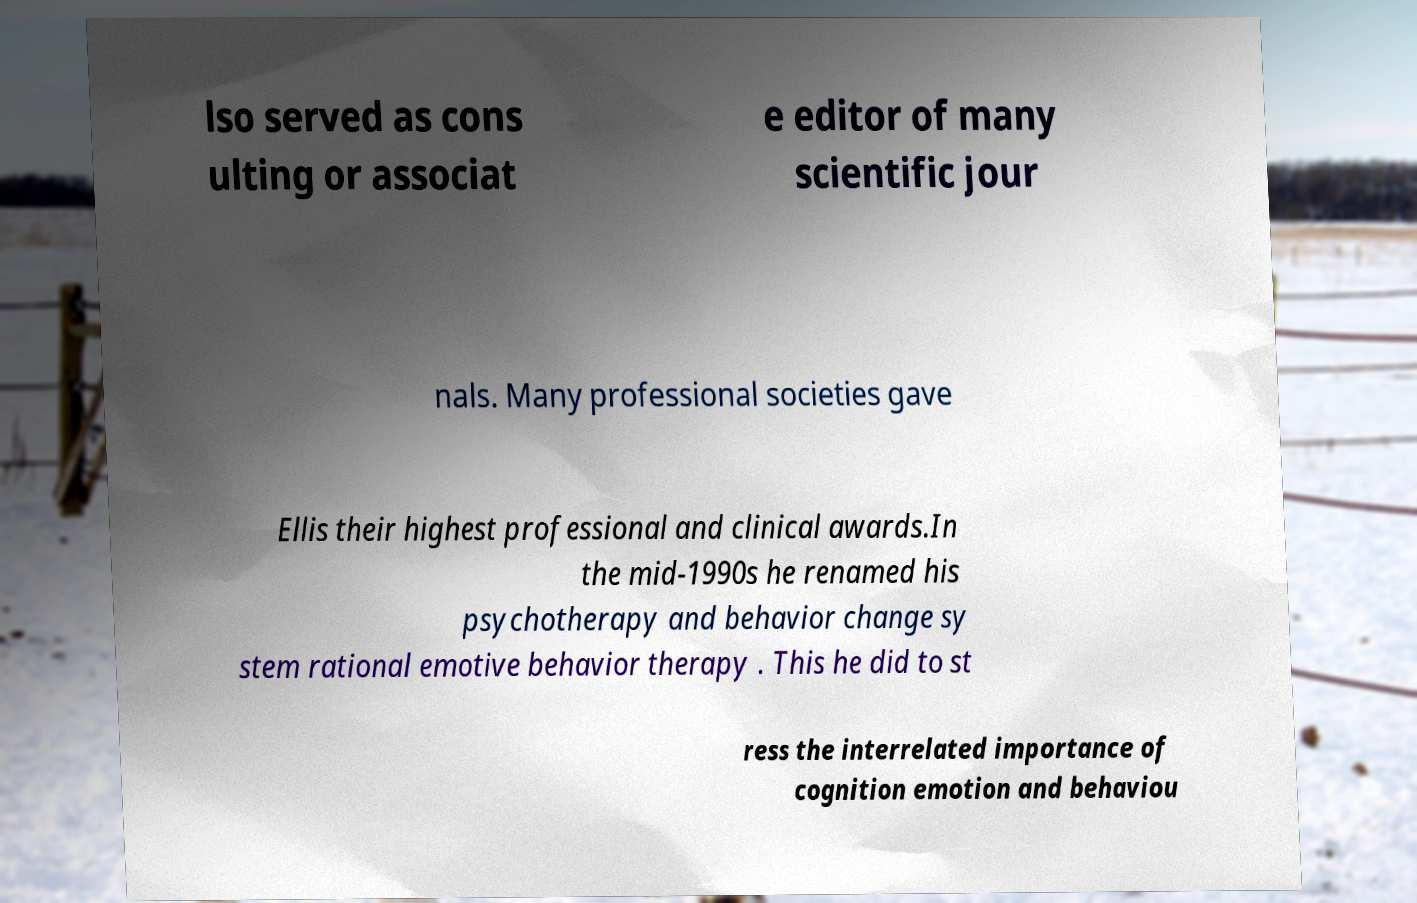Could you assist in decoding the text presented in this image and type it out clearly? lso served as cons ulting or associat e editor of many scientific jour nals. Many professional societies gave Ellis their highest professional and clinical awards.In the mid-1990s he renamed his psychotherapy and behavior change sy stem rational emotive behavior therapy . This he did to st ress the interrelated importance of cognition emotion and behaviou 